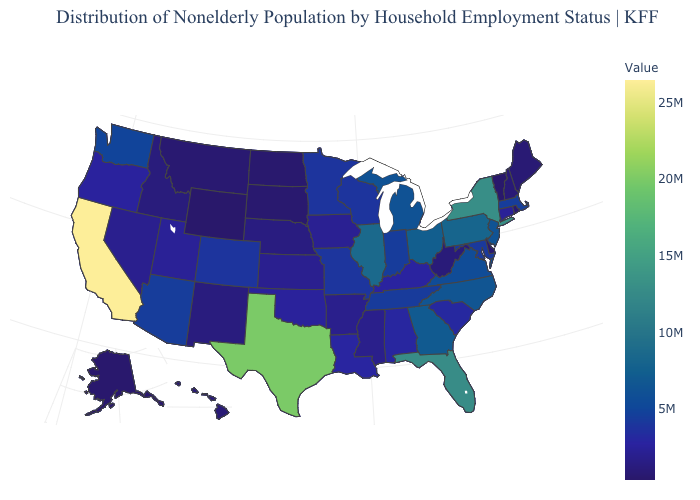Among the states that border Oklahoma , which have the highest value?
Answer briefly. Texas. Does Arizona have the highest value in the West?
Keep it brief. No. Does California have a lower value than Illinois?
Be succinct. No. 